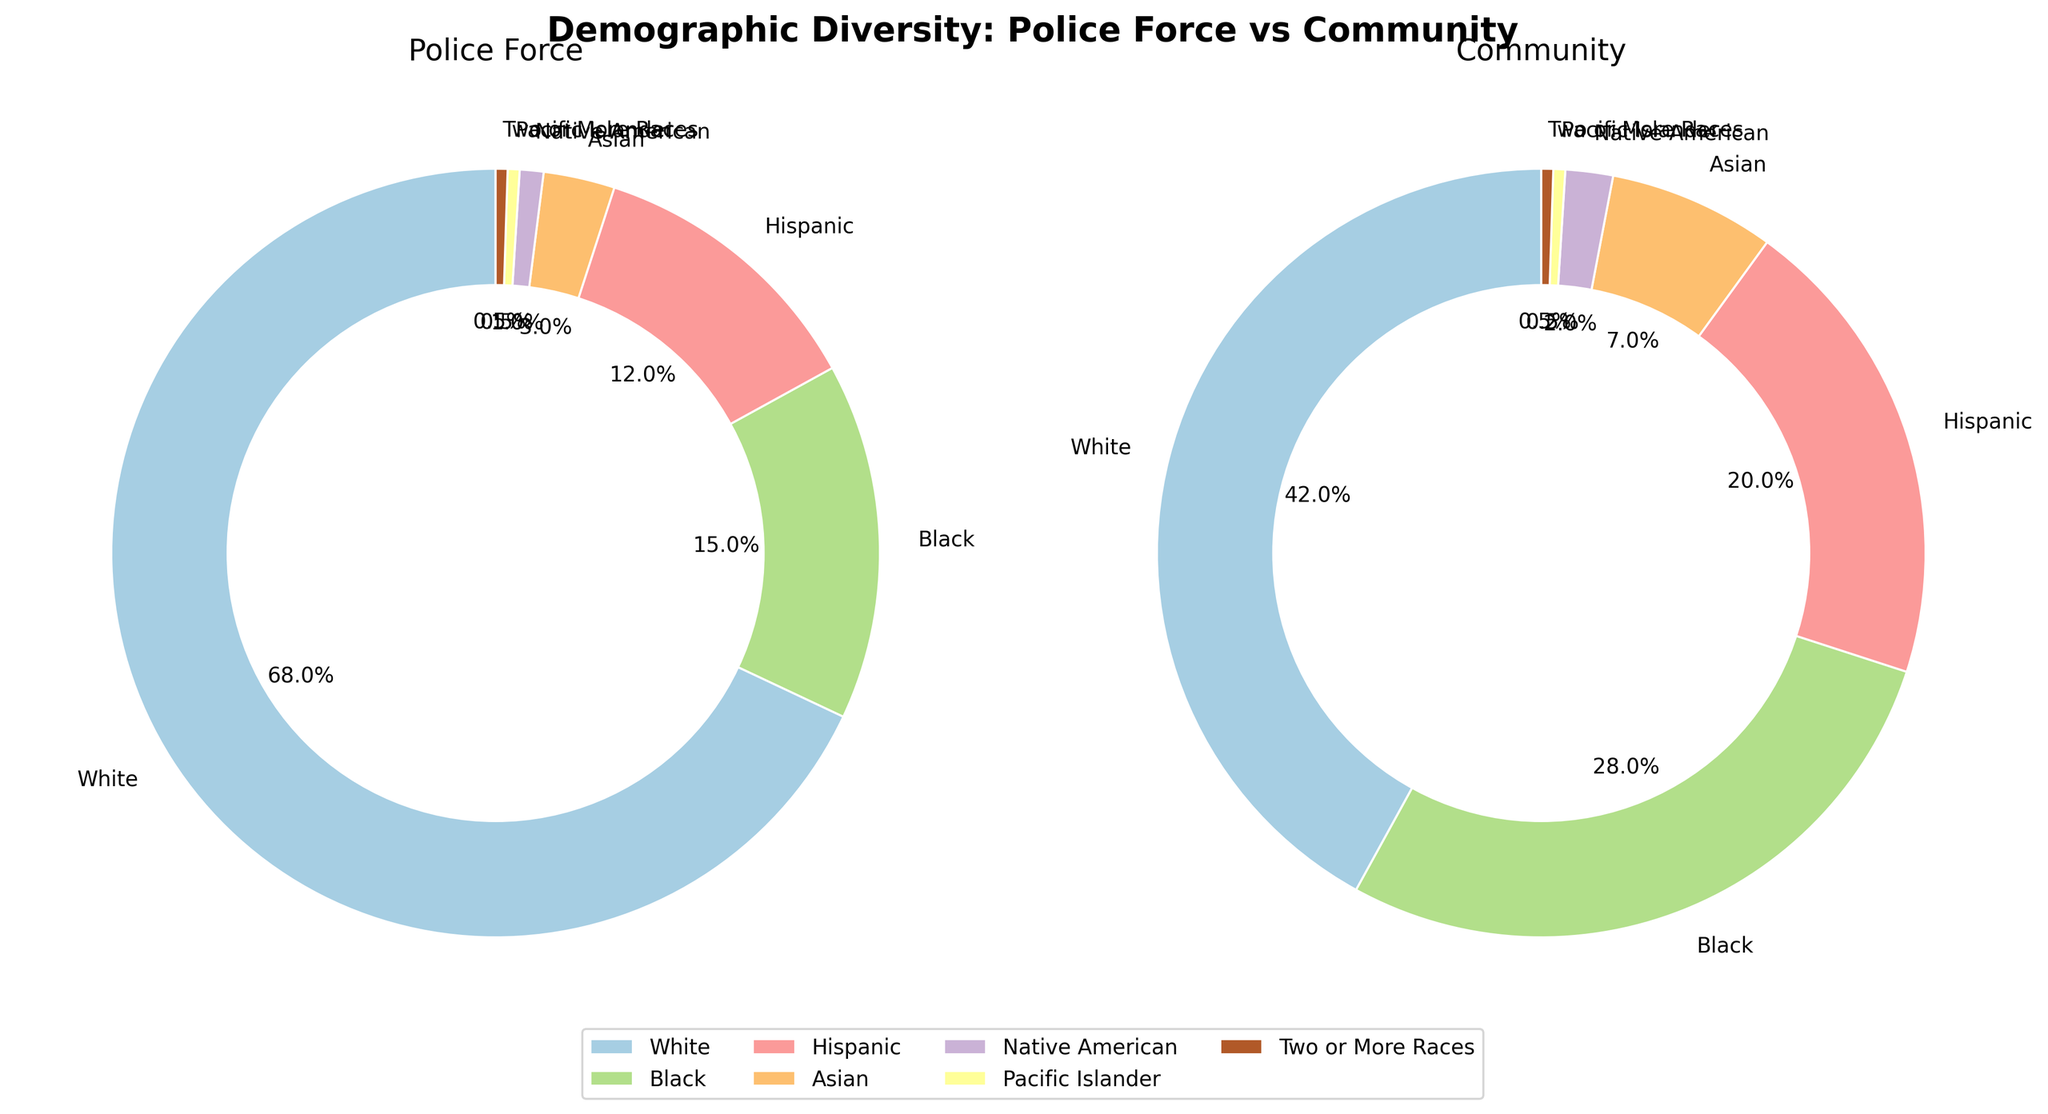Which racial group has the largest percentage discrepancy between the police force and the community? The largest discrepancy is found by calculating the absolute difference between the police force percentage and the community percentage for each racial group. The differences are: White 68-42=26, Black 28-15=13, Hispanic 20-12=8, Asian 7-3=4, Native American 2-1=1, Pacific Islander 0.5-0.5=0, and Two or More Races 0.5-0.5=0. The largest difference is 26 for the White group.
Answer: White Which racial group representation is equal in both the police force and the community? By comparing the percentages of each racial group represented in both the police force and the community, Pacific Islander and Two or More Races both have the same percentage for the police force and the community, at 0.5%.
Answer: Pacific Islander, Two or More Races What percentage of the police force is made up of Black and Hispanic officers combined? Sum the percentages of Black and Hispanic officers in the police force: 15% (Black) + 12% (Hispanic) = 27%.
Answer: 27% How does the representation of Asian individuals compare between the police force and the community? For Asian individuals, the police force percentage is 3%, while the community percentage is 7%. To compare, subtract the police force percentage from the community percentage: 7% - 3% = 4%. Thus, the community has a 4% higher representation of Asians than the police force.
Answer: The community has 4% more Asians Which racial group has the smallest representation in the police force? By observing the pie chart segments for percentages, the smallest representation in the police force is shared by Pacific Islander and Two or More Races, each with 0.5%.
Answer: Pacific Islander, Two or More Races 